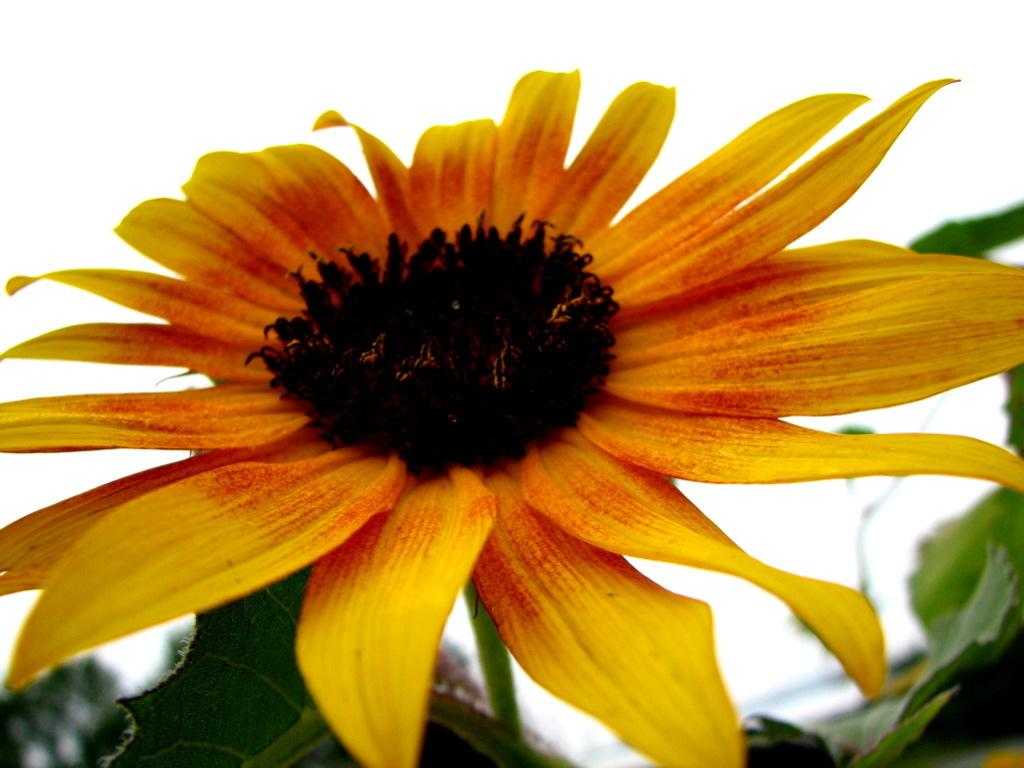What type of flower is in the image? There is a yellow flower in the image. What other parts of the flower can be seen besides the petals? The flower has leaves. What color is the background of the image? The background of the image is white. What type of toothbrush does the woman use in the image? There is no woman or toothbrush present in the image; it only features a yellow flower with leaves against a white background. 